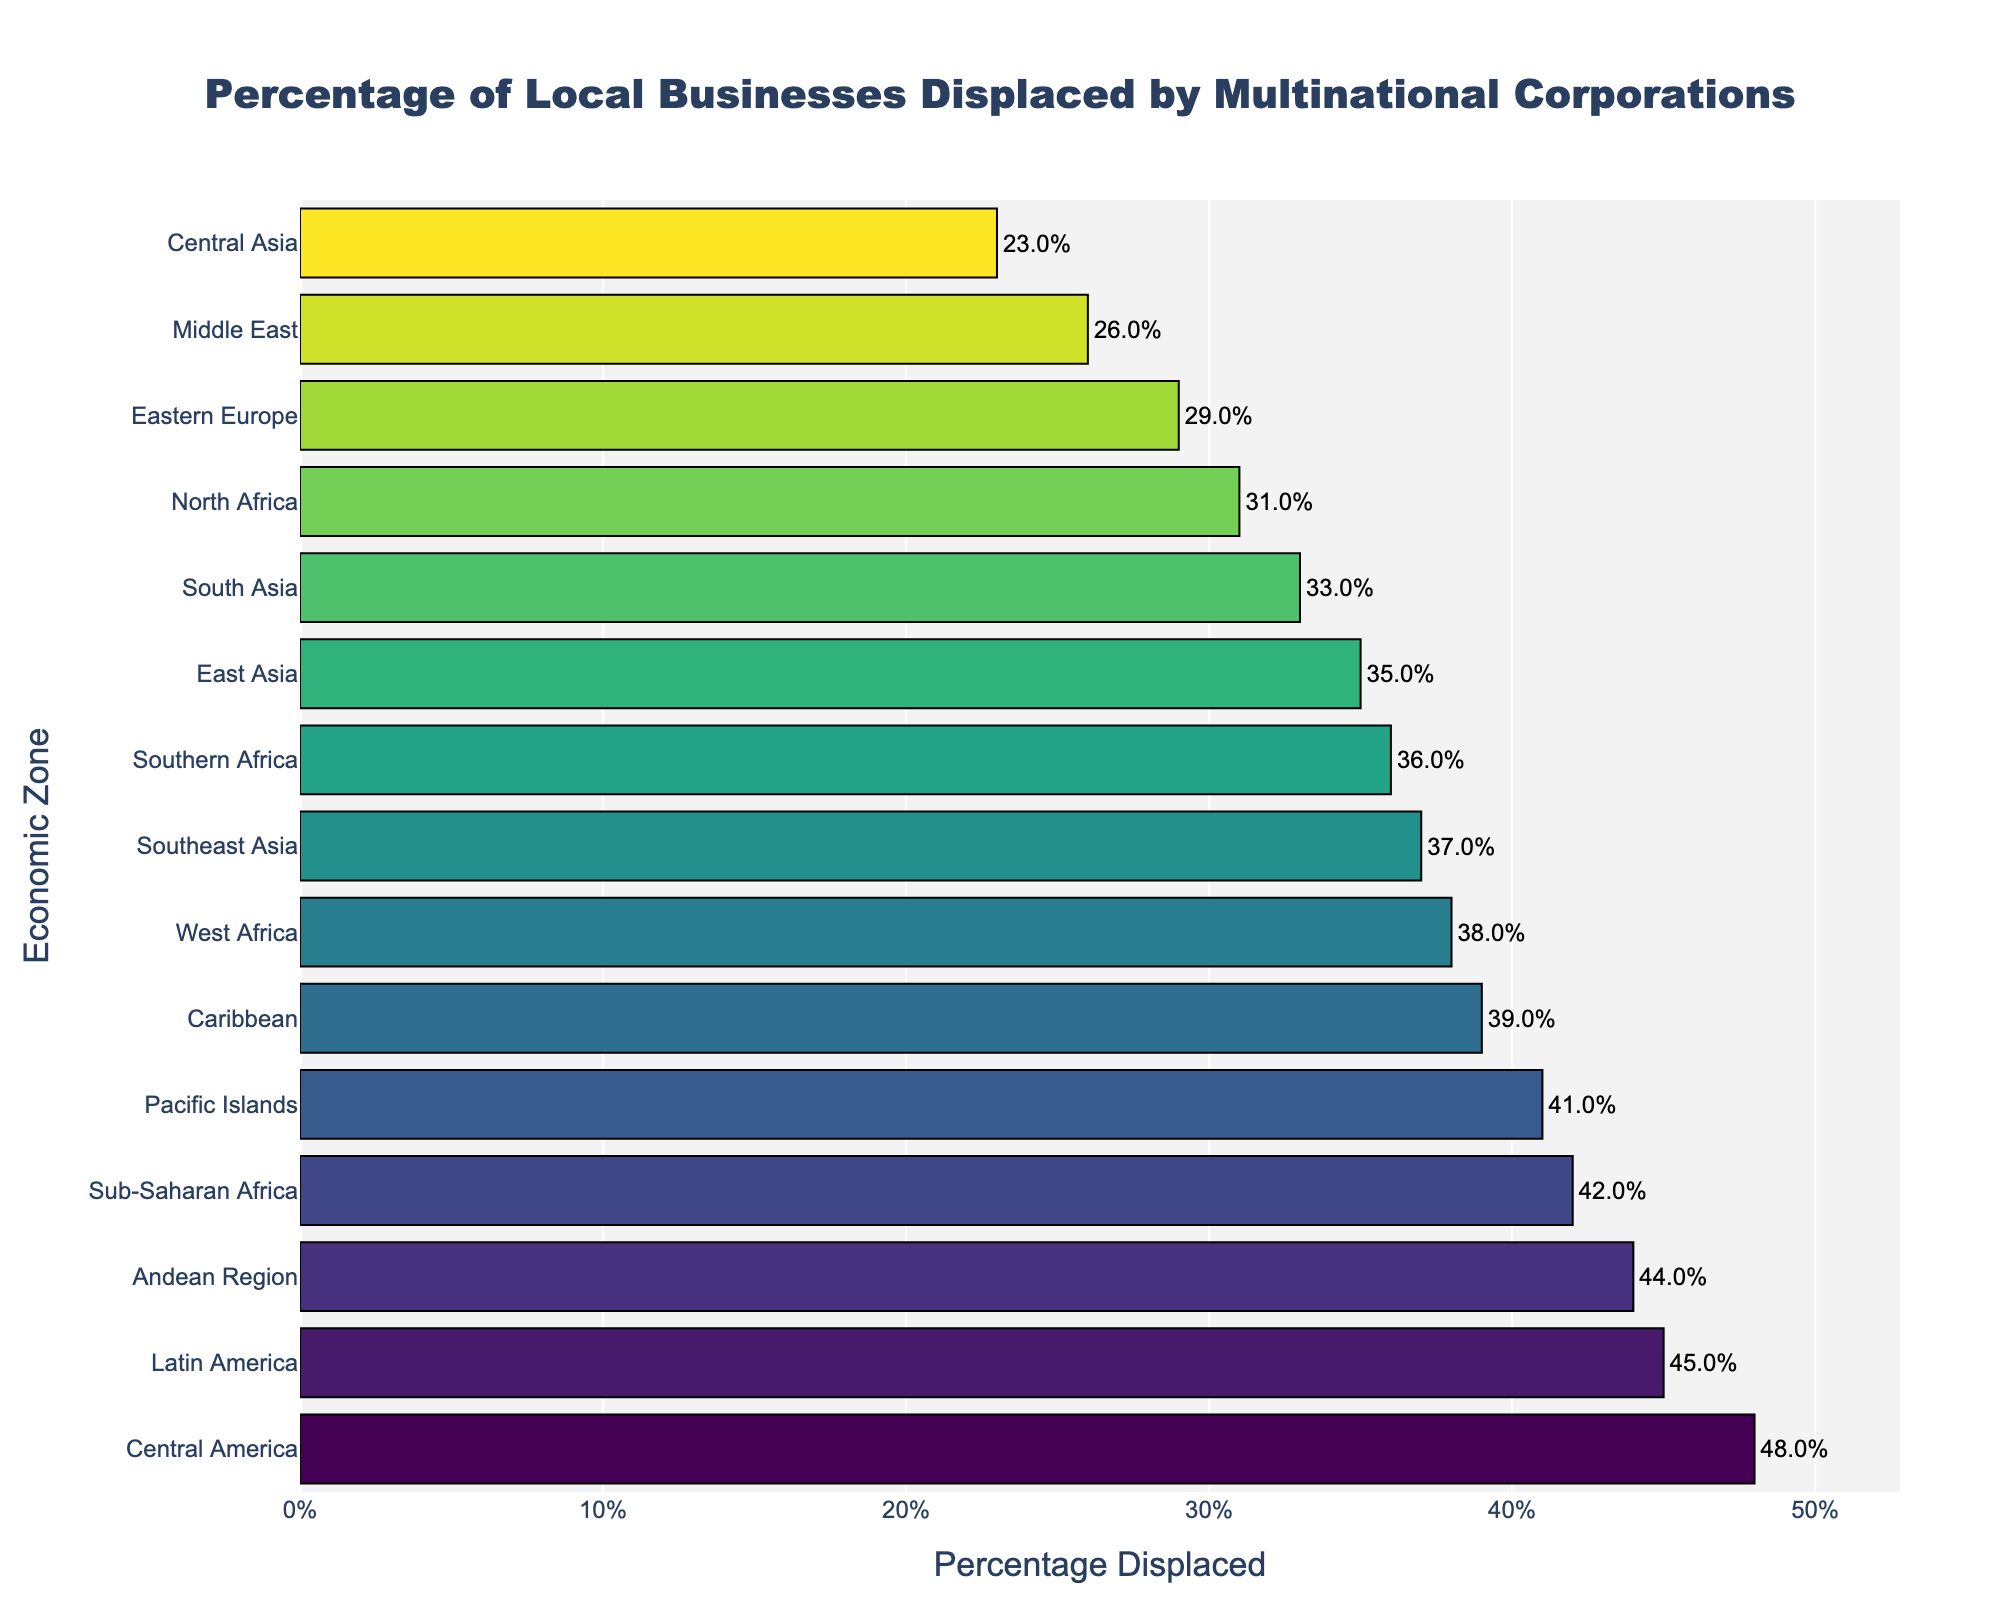What is the economic zone with the highest percentage of local businesses displaced? Look at the topmost bar in the bar chart since the data is sorted in descending order based on the percentage of local businesses displaced.
Answer: Central America Compare the percentage of local businesses displaced in Southeast Asia and East Asia. Which region has a higher percentage? Locate the bars for Southeast Asia and East Asia. Compare their lengths or the numerical values. Southeast Asia has a higher percentage (37%) compared to East Asia (35%).
Answer: Southeast Asia What is the difference between the percentage of local businesses displaced in Latin America and the Middle East? Find the bars for Latin America and the Middle East, then subtract the percentage for the Middle East (26%) from that for Latin America (45%).
Answer: 19% Calculate the average percentage of local businesses displaced across all the economic zones listed. Sum the percentages for all economic zones and divide by the number of zones. (37+42+29+45+33+26+39+48+31+23+35+41+44+38+36) / 15 = 37.5
Answer: 37.5% Which three economic zones have the lowest percentages of local businesses displaced? Look at the bottom three bars in the chart, corresponding to the lowest values. These are Central Asia (23%), Middle East (26%), and Eastern Europe (29%).
Answer: Central Asia, Middle East, Eastern Europe Between Southern Africa and the Andean Region, which economic zone has a lower rate of local business displacement? Locate the bars for Southern Africa (36%) and the Andean Region (44%). Since 36% is less than 44%, Southern Africa has a lower rate.
Answer: Southern Africa Identify the economic zones where the percentage of local businesses displaced is above 40%. Identify and list the bars that have values greater than 40%. These are Sub-Saharan Africa (42%), Latin America (45%), Central America (48%), and Andean Region (44%).
Answer: Sub-Saharan Africa, Latin America, Central America, Andean Region What is the range of the percentage values for local businesses displaced? The range is calculated as the difference between the maximum and minimum values. The maximum value is 48% (Central America) and the minimum is 23% (Central Asia).
Answer: 25% How many economic zones have a percentage of local businesses displaced greater than the average? First, determine the average percentage (37.5%). Then count the number of economic zones with values greater than 37.5%. These are Sub-Saharan Africa (42%), Latin America (45%), Central America (48%), Caribbean (39%), Pacific Islands (41%), and Andean Region (44%), totaling 6 zones.
Answer: 6 